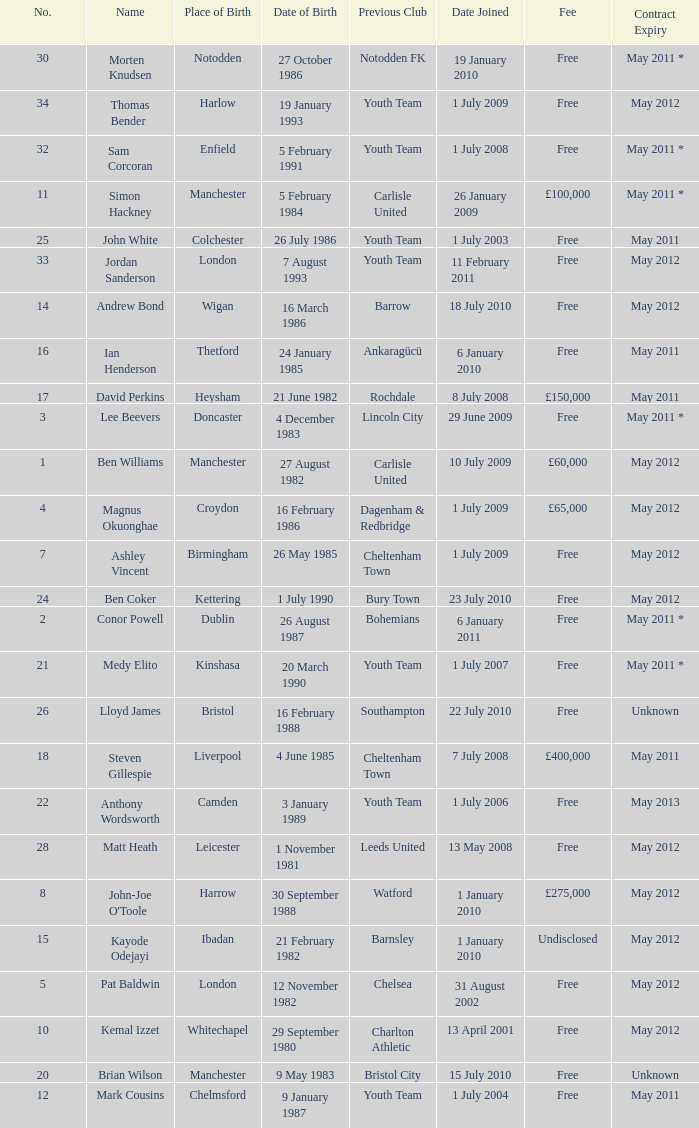What is the fee for ankaragücü previous club Free. 